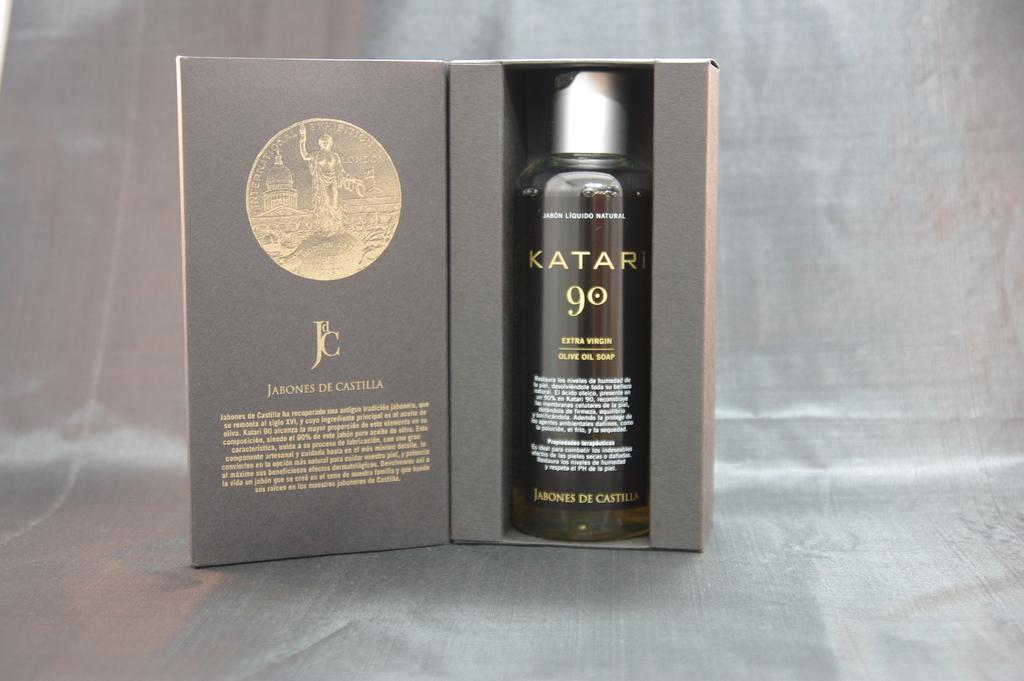Provide a one-sentence caption for the provided image. A bottle of Katari olive oil soap sits in a box. 